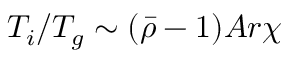Convert formula to latex. <formula><loc_0><loc_0><loc_500><loc_500>T _ { i } / T _ { g } \sim ( \bar { \rho } - 1 ) A r \chi</formula> 